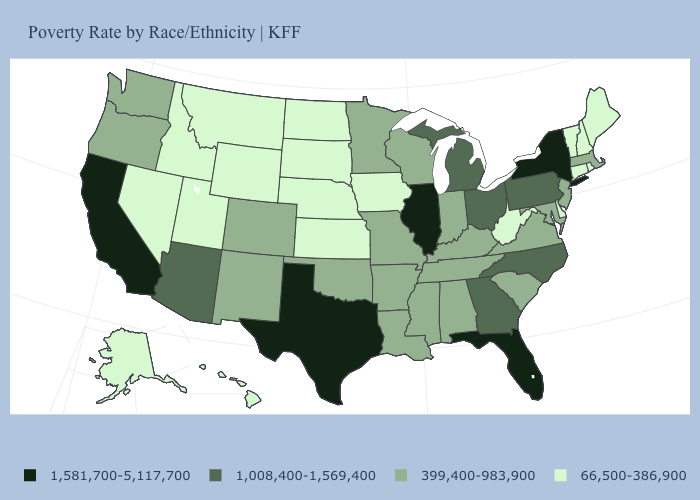Among the states that border Montana , which have the lowest value?
Quick response, please. Idaho, North Dakota, South Dakota, Wyoming. What is the value of Colorado?
Give a very brief answer. 399,400-983,900. Among the states that border Rhode Island , which have the highest value?
Concise answer only. Massachusetts. Does New Hampshire have a lower value than Maryland?
Keep it brief. Yes. What is the value of Florida?
Quick response, please. 1,581,700-5,117,700. Does the first symbol in the legend represent the smallest category?
Keep it brief. No. Name the states that have a value in the range 66,500-386,900?
Answer briefly. Alaska, Connecticut, Delaware, Hawaii, Idaho, Iowa, Kansas, Maine, Montana, Nebraska, Nevada, New Hampshire, North Dakota, Rhode Island, South Dakota, Utah, Vermont, West Virginia, Wyoming. Does Delaware have the highest value in the USA?
Answer briefly. No. Does the first symbol in the legend represent the smallest category?
Write a very short answer. No. Does Minnesota have a lower value than California?
Write a very short answer. Yes. Among the states that border Wyoming , does Utah have the lowest value?
Concise answer only. Yes. What is the highest value in the USA?
Concise answer only. 1,581,700-5,117,700. What is the value of Montana?
Give a very brief answer. 66,500-386,900. Does Illinois have a higher value than Tennessee?
Keep it brief. Yes. Is the legend a continuous bar?
Answer briefly. No. 